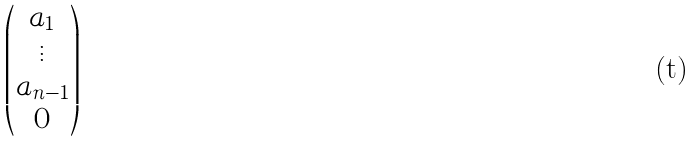Convert formula to latex. <formula><loc_0><loc_0><loc_500><loc_500>\begin{pmatrix} a _ { 1 } \\ \vdots \\ a _ { n - 1 } \\ 0 \end{pmatrix}</formula> 